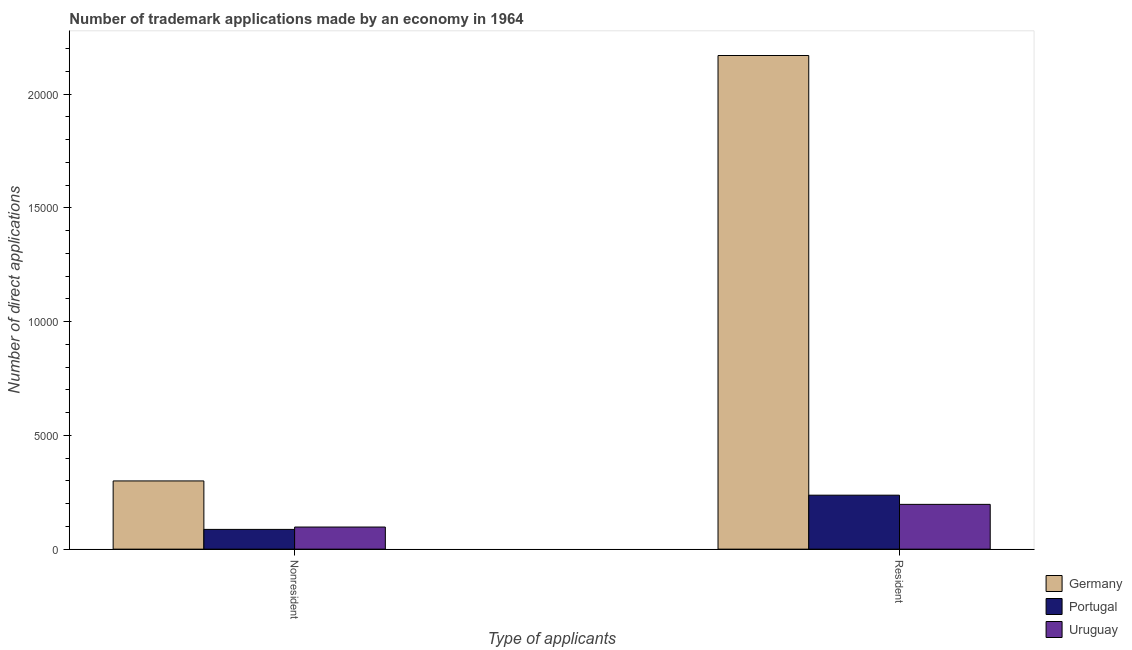Are the number of bars per tick equal to the number of legend labels?
Offer a very short reply. Yes. How many bars are there on the 2nd tick from the left?
Ensure brevity in your answer.  3. How many bars are there on the 1st tick from the right?
Your response must be concise. 3. What is the label of the 2nd group of bars from the left?
Provide a short and direct response. Resident. What is the number of trademark applications made by non residents in Uruguay?
Keep it short and to the point. 972. Across all countries, what is the maximum number of trademark applications made by non residents?
Provide a succinct answer. 2998. Across all countries, what is the minimum number of trademark applications made by non residents?
Offer a very short reply. 868. In which country was the number of trademark applications made by non residents maximum?
Make the answer very short. Germany. In which country was the number of trademark applications made by residents minimum?
Your answer should be very brief. Uruguay. What is the total number of trademark applications made by residents in the graph?
Offer a terse response. 2.60e+04. What is the difference between the number of trademark applications made by residents in Germany and that in Uruguay?
Make the answer very short. 1.97e+04. What is the difference between the number of trademark applications made by residents in Germany and the number of trademark applications made by non residents in Uruguay?
Provide a short and direct response. 2.07e+04. What is the average number of trademark applications made by residents per country?
Ensure brevity in your answer.  8678.67. What is the difference between the number of trademark applications made by residents and number of trademark applications made by non residents in Germany?
Give a very brief answer. 1.87e+04. In how many countries, is the number of trademark applications made by non residents greater than 6000 ?
Make the answer very short. 0. What is the ratio of the number of trademark applications made by residents in Portugal to that in Uruguay?
Your answer should be very brief. 1.21. Is the number of trademark applications made by residents in Portugal less than that in Uruguay?
Your answer should be very brief. No. In how many countries, is the number of trademark applications made by non residents greater than the average number of trademark applications made by non residents taken over all countries?
Make the answer very short. 1. What does the 3rd bar from the left in Resident represents?
Provide a short and direct response. Uruguay. What does the 3rd bar from the right in Resident represents?
Your answer should be compact. Germany. How many bars are there?
Your response must be concise. 6. Are all the bars in the graph horizontal?
Keep it short and to the point. No. How many countries are there in the graph?
Provide a succinct answer. 3. What is the difference between two consecutive major ticks on the Y-axis?
Your response must be concise. 5000. Are the values on the major ticks of Y-axis written in scientific E-notation?
Your answer should be compact. No. Does the graph contain grids?
Your answer should be compact. No. Where does the legend appear in the graph?
Your answer should be compact. Bottom right. How many legend labels are there?
Give a very brief answer. 3. How are the legend labels stacked?
Your answer should be compact. Vertical. What is the title of the graph?
Provide a short and direct response. Number of trademark applications made by an economy in 1964. What is the label or title of the X-axis?
Ensure brevity in your answer.  Type of applicants. What is the label or title of the Y-axis?
Your response must be concise. Number of direct applications. What is the Number of direct applications of Germany in Nonresident?
Your answer should be very brief. 2998. What is the Number of direct applications in Portugal in Nonresident?
Your answer should be very brief. 868. What is the Number of direct applications in Uruguay in Nonresident?
Ensure brevity in your answer.  972. What is the Number of direct applications in Germany in Resident?
Your response must be concise. 2.17e+04. What is the Number of direct applications in Portugal in Resident?
Give a very brief answer. 2372. What is the Number of direct applications of Uruguay in Resident?
Keep it short and to the point. 1968. Across all Type of applicants, what is the maximum Number of direct applications of Germany?
Your answer should be compact. 2.17e+04. Across all Type of applicants, what is the maximum Number of direct applications in Portugal?
Provide a succinct answer. 2372. Across all Type of applicants, what is the maximum Number of direct applications in Uruguay?
Give a very brief answer. 1968. Across all Type of applicants, what is the minimum Number of direct applications of Germany?
Your answer should be very brief. 2998. Across all Type of applicants, what is the minimum Number of direct applications in Portugal?
Make the answer very short. 868. Across all Type of applicants, what is the minimum Number of direct applications of Uruguay?
Give a very brief answer. 972. What is the total Number of direct applications in Germany in the graph?
Ensure brevity in your answer.  2.47e+04. What is the total Number of direct applications in Portugal in the graph?
Give a very brief answer. 3240. What is the total Number of direct applications of Uruguay in the graph?
Ensure brevity in your answer.  2940. What is the difference between the Number of direct applications of Germany in Nonresident and that in Resident?
Give a very brief answer. -1.87e+04. What is the difference between the Number of direct applications of Portugal in Nonresident and that in Resident?
Give a very brief answer. -1504. What is the difference between the Number of direct applications in Uruguay in Nonresident and that in Resident?
Give a very brief answer. -996. What is the difference between the Number of direct applications of Germany in Nonresident and the Number of direct applications of Portugal in Resident?
Your response must be concise. 626. What is the difference between the Number of direct applications in Germany in Nonresident and the Number of direct applications in Uruguay in Resident?
Your answer should be compact. 1030. What is the difference between the Number of direct applications in Portugal in Nonresident and the Number of direct applications in Uruguay in Resident?
Make the answer very short. -1100. What is the average Number of direct applications of Germany per Type of applicants?
Provide a short and direct response. 1.23e+04. What is the average Number of direct applications of Portugal per Type of applicants?
Provide a succinct answer. 1620. What is the average Number of direct applications in Uruguay per Type of applicants?
Ensure brevity in your answer.  1470. What is the difference between the Number of direct applications in Germany and Number of direct applications in Portugal in Nonresident?
Make the answer very short. 2130. What is the difference between the Number of direct applications in Germany and Number of direct applications in Uruguay in Nonresident?
Your response must be concise. 2026. What is the difference between the Number of direct applications in Portugal and Number of direct applications in Uruguay in Nonresident?
Make the answer very short. -104. What is the difference between the Number of direct applications of Germany and Number of direct applications of Portugal in Resident?
Keep it short and to the point. 1.93e+04. What is the difference between the Number of direct applications of Germany and Number of direct applications of Uruguay in Resident?
Offer a terse response. 1.97e+04. What is the difference between the Number of direct applications of Portugal and Number of direct applications of Uruguay in Resident?
Offer a very short reply. 404. What is the ratio of the Number of direct applications of Germany in Nonresident to that in Resident?
Offer a very short reply. 0.14. What is the ratio of the Number of direct applications in Portugal in Nonresident to that in Resident?
Ensure brevity in your answer.  0.37. What is the ratio of the Number of direct applications in Uruguay in Nonresident to that in Resident?
Provide a succinct answer. 0.49. What is the difference between the highest and the second highest Number of direct applications of Germany?
Your response must be concise. 1.87e+04. What is the difference between the highest and the second highest Number of direct applications in Portugal?
Your answer should be compact. 1504. What is the difference between the highest and the second highest Number of direct applications of Uruguay?
Give a very brief answer. 996. What is the difference between the highest and the lowest Number of direct applications of Germany?
Ensure brevity in your answer.  1.87e+04. What is the difference between the highest and the lowest Number of direct applications in Portugal?
Keep it short and to the point. 1504. What is the difference between the highest and the lowest Number of direct applications of Uruguay?
Your response must be concise. 996. 